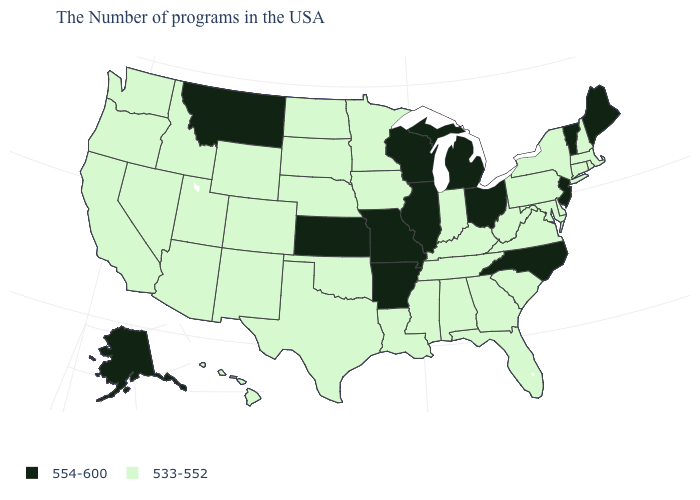What is the value of Montana?
Answer briefly. 554-600. What is the value of Washington?
Answer briefly. 533-552. What is the value of Idaho?
Give a very brief answer. 533-552. How many symbols are there in the legend?
Be succinct. 2. Is the legend a continuous bar?
Concise answer only. No. What is the value of Wyoming?
Concise answer only. 533-552. Name the states that have a value in the range 533-552?
Quick response, please. Massachusetts, Rhode Island, New Hampshire, Connecticut, New York, Delaware, Maryland, Pennsylvania, Virginia, South Carolina, West Virginia, Florida, Georgia, Kentucky, Indiana, Alabama, Tennessee, Mississippi, Louisiana, Minnesota, Iowa, Nebraska, Oklahoma, Texas, South Dakota, North Dakota, Wyoming, Colorado, New Mexico, Utah, Arizona, Idaho, Nevada, California, Washington, Oregon, Hawaii. What is the highest value in the USA?
Concise answer only. 554-600. How many symbols are there in the legend?
Write a very short answer. 2. What is the value of Mississippi?
Concise answer only. 533-552. Is the legend a continuous bar?
Short answer required. No. What is the value of West Virginia?
Give a very brief answer. 533-552. Does the map have missing data?
Write a very short answer. No. Among the states that border Missouri , does Iowa have the lowest value?
Be succinct. Yes. 